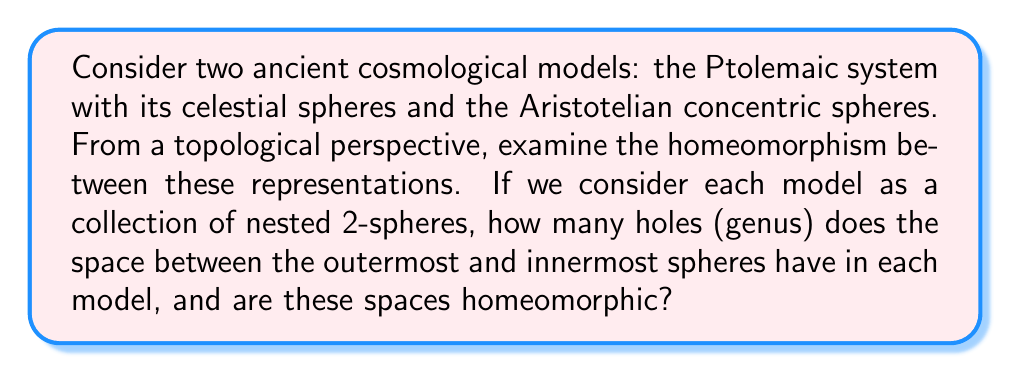Give your solution to this math problem. To approach this problem, we need to consider the topological properties of the two cosmological models:

1. Ptolemaic system:
   The Ptolemaic system consists of nested spheres with epicycles. Topologically, we can simplify this to a series of nested 2-spheres.

2. Aristotelian concentric spheres:
   This model consists of perfectly concentric nested spheres.

In both cases, we're interested in the space between the outermost and innermost spheres.

For a single spherical shell (the space between two concentric spheres), the topology is equivalent to $S^2 \times [0,1]$, where $S^2$ is a 2-sphere and $[0,1]$ is a closed interval.

The genus of a surface is the number of holes it has. For a spherical shell, there are no holes passing through it, so the genus is 0.

Now, let's consider the space between the outermost and innermost spheres in each model:

1. Ptolemaic system:
   Despite the complexity of epicycles, topologically, this space is still equivalent to a series of nested spherical shells. The space between any two consecutive shells is homeomorphic to $S^2 \times [0,1]$, and the entire space is homeomorphic to $S^2 \times [0,1]$ as well.

2. Aristotelian concentric spheres:
   This is straightforwardly a series of nested spherical shells, also homeomorphic to $S^2 \times [0,1]$.

In both cases, the space between the outermost and innermost spheres has a genus of 0, as there are no holes passing through the entire structure.

Furthermore, these spaces are indeed homeomorphic to each other. A homeomorphism can be constructed by a continuous deformation that maps the spheres of one model to the other, preserving the nested structure and the topology of the space between them.
Answer: The space between the outermost and innermost spheres in both the Ptolemaic and Aristotelian models has a genus of 0. These spaces are homeomorphic to each other and to $S^2 \times [0,1]$. 